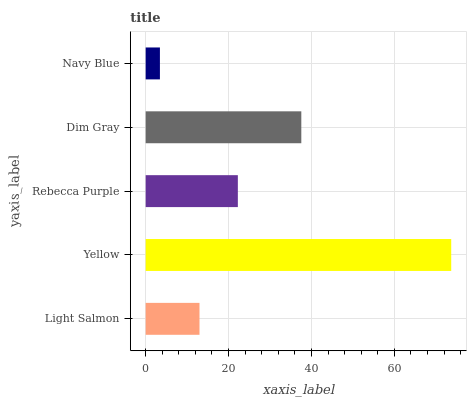Is Navy Blue the minimum?
Answer yes or no. Yes. Is Yellow the maximum?
Answer yes or no. Yes. Is Rebecca Purple the minimum?
Answer yes or no. No. Is Rebecca Purple the maximum?
Answer yes or no. No. Is Yellow greater than Rebecca Purple?
Answer yes or no. Yes. Is Rebecca Purple less than Yellow?
Answer yes or no. Yes. Is Rebecca Purple greater than Yellow?
Answer yes or no. No. Is Yellow less than Rebecca Purple?
Answer yes or no. No. Is Rebecca Purple the high median?
Answer yes or no. Yes. Is Rebecca Purple the low median?
Answer yes or no. Yes. Is Dim Gray the high median?
Answer yes or no. No. Is Navy Blue the low median?
Answer yes or no. No. 